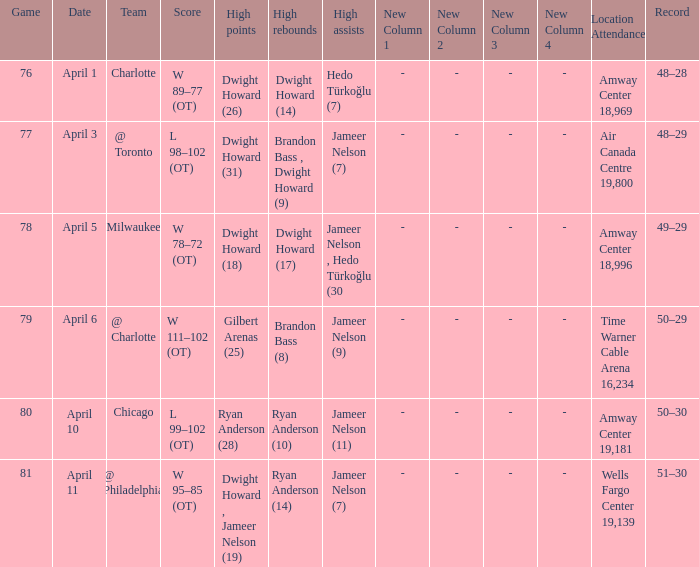Where was the game and what was the attendance on April 3?  Air Canada Centre 19,800. 